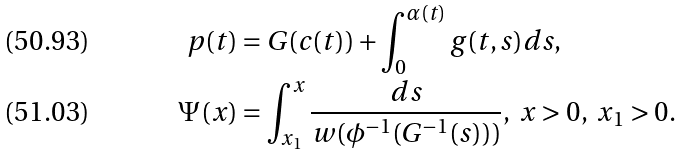<formula> <loc_0><loc_0><loc_500><loc_500>p ( t ) & = G ( c ( t ) ) + \int _ { 0 } ^ { \alpha ( t ) } g ( t , s ) d s , \\ \Psi ( x ) & = \int _ { x _ { 1 } } ^ { x } \frac { d s } { w ( \phi ^ { - 1 } ( G ^ { - 1 } ( s ) ) ) } , \ x > 0 , \ x _ { 1 } > 0 .</formula> 